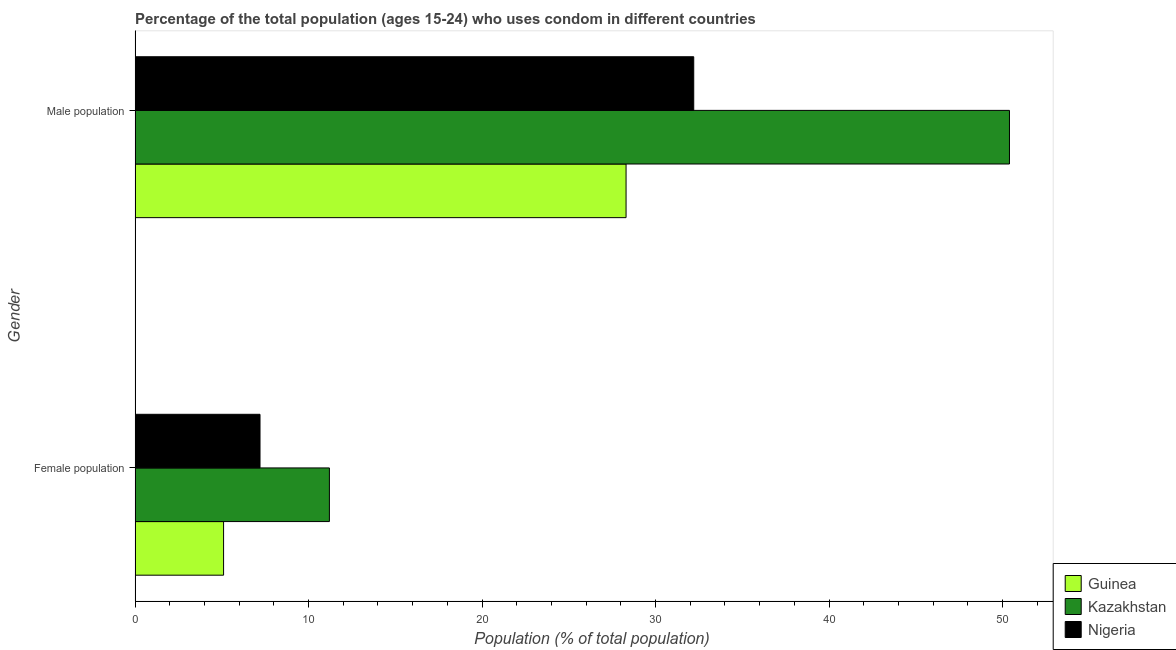How many different coloured bars are there?
Offer a very short reply. 3. How many groups of bars are there?
Your answer should be very brief. 2. How many bars are there on the 2nd tick from the top?
Offer a very short reply. 3. What is the label of the 1st group of bars from the top?
Your response must be concise. Male population. What is the male population in Guinea?
Offer a very short reply. 28.3. Across all countries, what is the maximum male population?
Give a very brief answer. 50.4. Across all countries, what is the minimum male population?
Provide a succinct answer. 28.3. In which country was the male population maximum?
Keep it short and to the point. Kazakhstan. In which country was the female population minimum?
Give a very brief answer. Guinea. What is the total female population in the graph?
Give a very brief answer. 23.5. What is the difference between the female population in Kazakhstan and that in Nigeria?
Make the answer very short. 4. What is the difference between the female population in Kazakhstan and the male population in Guinea?
Offer a very short reply. -17.1. What is the average male population per country?
Your answer should be compact. 36.97. What is the difference between the female population and male population in Nigeria?
Make the answer very short. -25. What is the ratio of the female population in Nigeria to that in Kazakhstan?
Your answer should be compact. 0.64. Is the male population in Kazakhstan less than that in Guinea?
Your answer should be compact. No. In how many countries, is the female population greater than the average female population taken over all countries?
Ensure brevity in your answer.  1. What does the 3rd bar from the top in Male population represents?
Offer a very short reply. Guinea. What does the 3rd bar from the bottom in Male population represents?
Provide a succinct answer. Nigeria. What is the difference between two consecutive major ticks on the X-axis?
Offer a very short reply. 10. Are the values on the major ticks of X-axis written in scientific E-notation?
Offer a terse response. No. Does the graph contain any zero values?
Ensure brevity in your answer.  No. How many legend labels are there?
Ensure brevity in your answer.  3. How are the legend labels stacked?
Your response must be concise. Vertical. What is the title of the graph?
Provide a short and direct response. Percentage of the total population (ages 15-24) who uses condom in different countries. Does "Eritrea" appear as one of the legend labels in the graph?
Your response must be concise. No. What is the label or title of the X-axis?
Keep it short and to the point. Population (% of total population) . What is the Population (% of total population)  of Guinea in Female population?
Your response must be concise. 5.1. What is the Population (% of total population)  in Nigeria in Female population?
Offer a very short reply. 7.2. What is the Population (% of total population)  of Guinea in Male population?
Ensure brevity in your answer.  28.3. What is the Population (% of total population)  of Kazakhstan in Male population?
Your answer should be compact. 50.4. What is the Population (% of total population)  of Nigeria in Male population?
Offer a very short reply. 32.2. Across all Gender, what is the maximum Population (% of total population)  in Guinea?
Your answer should be very brief. 28.3. Across all Gender, what is the maximum Population (% of total population)  in Kazakhstan?
Your answer should be very brief. 50.4. Across all Gender, what is the maximum Population (% of total population)  in Nigeria?
Your answer should be compact. 32.2. Across all Gender, what is the minimum Population (% of total population)  in Guinea?
Offer a very short reply. 5.1. Across all Gender, what is the minimum Population (% of total population)  of Kazakhstan?
Ensure brevity in your answer.  11.2. Across all Gender, what is the minimum Population (% of total population)  of Nigeria?
Provide a short and direct response. 7.2. What is the total Population (% of total population)  in Guinea in the graph?
Ensure brevity in your answer.  33.4. What is the total Population (% of total population)  in Kazakhstan in the graph?
Give a very brief answer. 61.6. What is the total Population (% of total population)  in Nigeria in the graph?
Make the answer very short. 39.4. What is the difference between the Population (% of total population)  of Guinea in Female population and that in Male population?
Offer a very short reply. -23.2. What is the difference between the Population (% of total population)  in Kazakhstan in Female population and that in Male population?
Provide a short and direct response. -39.2. What is the difference between the Population (% of total population)  of Nigeria in Female population and that in Male population?
Your answer should be compact. -25. What is the difference between the Population (% of total population)  in Guinea in Female population and the Population (% of total population)  in Kazakhstan in Male population?
Give a very brief answer. -45.3. What is the difference between the Population (% of total population)  in Guinea in Female population and the Population (% of total population)  in Nigeria in Male population?
Offer a terse response. -27.1. What is the average Population (% of total population)  in Guinea per Gender?
Provide a succinct answer. 16.7. What is the average Population (% of total population)  of Kazakhstan per Gender?
Give a very brief answer. 30.8. What is the difference between the Population (% of total population)  in Guinea and Population (% of total population)  in Kazakhstan in Male population?
Your answer should be compact. -22.1. What is the difference between the Population (% of total population)  in Kazakhstan and Population (% of total population)  in Nigeria in Male population?
Keep it short and to the point. 18.2. What is the ratio of the Population (% of total population)  in Guinea in Female population to that in Male population?
Ensure brevity in your answer.  0.18. What is the ratio of the Population (% of total population)  of Kazakhstan in Female population to that in Male population?
Ensure brevity in your answer.  0.22. What is the ratio of the Population (% of total population)  in Nigeria in Female population to that in Male population?
Your response must be concise. 0.22. What is the difference between the highest and the second highest Population (% of total population)  in Guinea?
Your response must be concise. 23.2. What is the difference between the highest and the second highest Population (% of total population)  in Kazakhstan?
Offer a very short reply. 39.2. What is the difference between the highest and the second highest Population (% of total population)  of Nigeria?
Keep it short and to the point. 25. What is the difference between the highest and the lowest Population (% of total population)  in Guinea?
Offer a very short reply. 23.2. What is the difference between the highest and the lowest Population (% of total population)  of Kazakhstan?
Offer a very short reply. 39.2. 